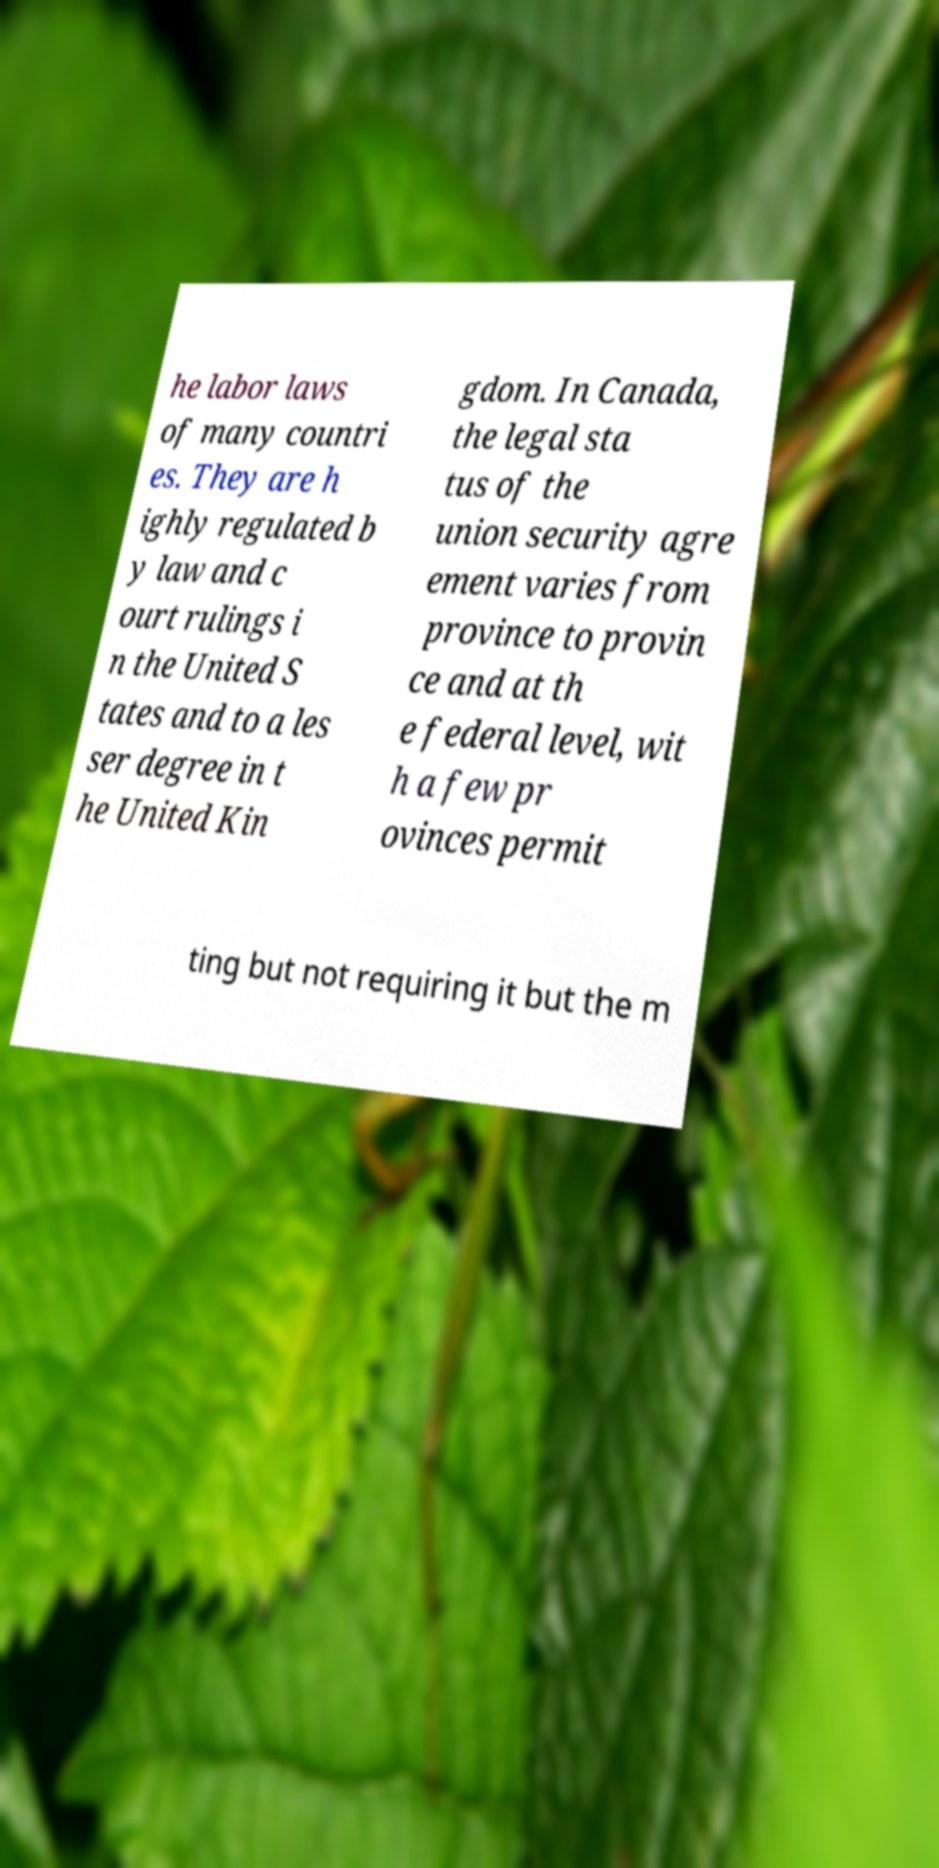Can you read and provide the text displayed in the image?This photo seems to have some interesting text. Can you extract and type it out for me? he labor laws of many countri es. They are h ighly regulated b y law and c ourt rulings i n the United S tates and to a les ser degree in t he United Kin gdom. In Canada, the legal sta tus of the union security agre ement varies from province to provin ce and at th e federal level, wit h a few pr ovinces permit ting but not requiring it but the m 